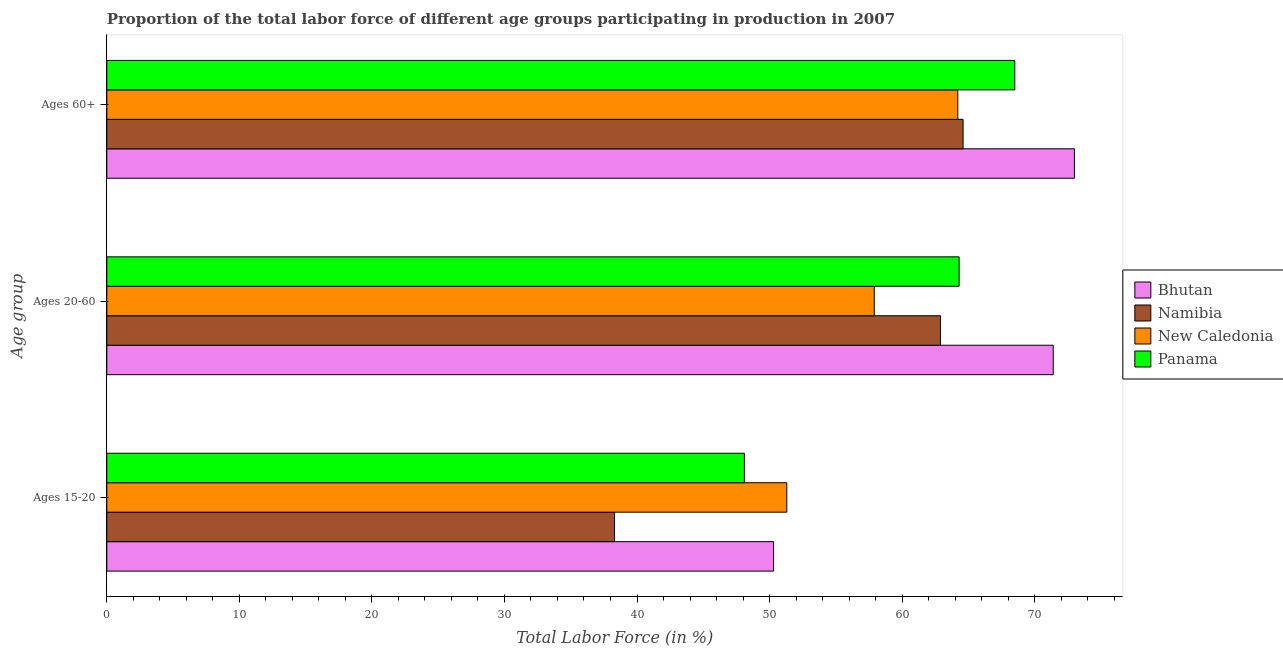Are the number of bars per tick equal to the number of legend labels?
Give a very brief answer. Yes. Are the number of bars on each tick of the Y-axis equal?
Ensure brevity in your answer.  Yes. How many bars are there on the 2nd tick from the top?
Offer a terse response. 4. What is the label of the 1st group of bars from the top?
Offer a terse response. Ages 60+. What is the percentage of labor force within the age group 20-60 in Bhutan?
Your answer should be compact. 71.4. Across all countries, what is the maximum percentage of labor force above age 60?
Provide a short and direct response. 73. Across all countries, what is the minimum percentage of labor force above age 60?
Provide a short and direct response. 64.2. In which country was the percentage of labor force above age 60 maximum?
Make the answer very short. Bhutan. In which country was the percentage of labor force above age 60 minimum?
Provide a succinct answer. New Caledonia. What is the total percentage of labor force above age 60 in the graph?
Ensure brevity in your answer.  270.3. What is the difference between the percentage of labor force within the age group 15-20 in New Caledonia and that in Namibia?
Ensure brevity in your answer.  13. What is the difference between the percentage of labor force within the age group 15-20 in Bhutan and the percentage of labor force above age 60 in New Caledonia?
Ensure brevity in your answer.  -13.9. What is the average percentage of labor force above age 60 per country?
Your response must be concise. 67.57. What is the difference between the percentage of labor force within the age group 20-60 and percentage of labor force within the age group 15-20 in Bhutan?
Provide a short and direct response. 21.1. In how many countries, is the percentage of labor force above age 60 greater than 24 %?
Your answer should be very brief. 4. What is the ratio of the percentage of labor force above age 60 in New Caledonia to that in Namibia?
Keep it short and to the point. 0.99. Is the percentage of labor force within the age group 20-60 in New Caledonia less than that in Bhutan?
Your response must be concise. Yes. Is the difference between the percentage of labor force above age 60 in Panama and New Caledonia greater than the difference between the percentage of labor force within the age group 20-60 in Panama and New Caledonia?
Your answer should be compact. No. What is the difference between the highest and the lowest percentage of labor force above age 60?
Your response must be concise. 8.8. Is the sum of the percentage of labor force within the age group 15-20 in Panama and Bhutan greater than the maximum percentage of labor force above age 60 across all countries?
Make the answer very short. Yes. What does the 4th bar from the top in Ages 60+ represents?
Your answer should be very brief. Bhutan. What does the 4th bar from the bottom in Ages 20-60 represents?
Your response must be concise. Panama. How many bars are there?
Offer a terse response. 12. Are all the bars in the graph horizontal?
Your answer should be very brief. Yes. How many countries are there in the graph?
Offer a very short reply. 4. What is the difference between two consecutive major ticks on the X-axis?
Your answer should be compact. 10. Does the graph contain grids?
Your response must be concise. No. Where does the legend appear in the graph?
Offer a terse response. Center right. How many legend labels are there?
Your answer should be very brief. 4. How are the legend labels stacked?
Your response must be concise. Vertical. What is the title of the graph?
Offer a very short reply. Proportion of the total labor force of different age groups participating in production in 2007. What is the label or title of the X-axis?
Provide a short and direct response. Total Labor Force (in %). What is the label or title of the Y-axis?
Your answer should be compact. Age group. What is the Total Labor Force (in %) in Bhutan in Ages 15-20?
Provide a short and direct response. 50.3. What is the Total Labor Force (in %) of Namibia in Ages 15-20?
Give a very brief answer. 38.3. What is the Total Labor Force (in %) of New Caledonia in Ages 15-20?
Your answer should be compact. 51.3. What is the Total Labor Force (in %) of Panama in Ages 15-20?
Give a very brief answer. 48.1. What is the Total Labor Force (in %) in Bhutan in Ages 20-60?
Keep it short and to the point. 71.4. What is the Total Labor Force (in %) in Namibia in Ages 20-60?
Your response must be concise. 62.9. What is the Total Labor Force (in %) in New Caledonia in Ages 20-60?
Your answer should be very brief. 57.9. What is the Total Labor Force (in %) of Panama in Ages 20-60?
Make the answer very short. 64.3. What is the Total Labor Force (in %) of Namibia in Ages 60+?
Provide a succinct answer. 64.6. What is the Total Labor Force (in %) of New Caledonia in Ages 60+?
Make the answer very short. 64.2. What is the Total Labor Force (in %) of Panama in Ages 60+?
Keep it short and to the point. 68.5. Across all Age group, what is the maximum Total Labor Force (in %) in Bhutan?
Your answer should be very brief. 73. Across all Age group, what is the maximum Total Labor Force (in %) of Namibia?
Give a very brief answer. 64.6. Across all Age group, what is the maximum Total Labor Force (in %) in New Caledonia?
Offer a terse response. 64.2. Across all Age group, what is the maximum Total Labor Force (in %) in Panama?
Your answer should be very brief. 68.5. Across all Age group, what is the minimum Total Labor Force (in %) in Bhutan?
Your answer should be compact. 50.3. Across all Age group, what is the minimum Total Labor Force (in %) of Namibia?
Provide a succinct answer. 38.3. Across all Age group, what is the minimum Total Labor Force (in %) in New Caledonia?
Ensure brevity in your answer.  51.3. Across all Age group, what is the minimum Total Labor Force (in %) in Panama?
Offer a very short reply. 48.1. What is the total Total Labor Force (in %) of Bhutan in the graph?
Keep it short and to the point. 194.7. What is the total Total Labor Force (in %) in Namibia in the graph?
Provide a short and direct response. 165.8. What is the total Total Labor Force (in %) of New Caledonia in the graph?
Your answer should be compact. 173.4. What is the total Total Labor Force (in %) in Panama in the graph?
Offer a terse response. 180.9. What is the difference between the Total Labor Force (in %) of Bhutan in Ages 15-20 and that in Ages 20-60?
Your answer should be very brief. -21.1. What is the difference between the Total Labor Force (in %) of Namibia in Ages 15-20 and that in Ages 20-60?
Give a very brief answer. -24.6. What is the difference between the Total Labor Force (in %) of Panama in Ages 15-20 and that in Ages 20-60?
Ensure brevity in your answer.  -16.2. What is the difference between the Total Labor Force (in %) of Bhutan in Ages 15-20 and that in Ages 60+?
Your answer should be compact. -22.7. What is the difference between the Total Labor Force (in %) of Namibia in Ages 15-20 and that in Ages 60+?
Give a very brief answer. -26.3. What is the difference between the Total Labor Force (in %) of New Caledonia in Ages 15-20 and that in Ages 60+?
Your answer should be very brief. -12.9. What is the difference between the Total Labor Force (in %) of Panama in Ages 15-20 and that in Ages 60+?
Your answer should be compact. -20.4. What is the difference between the Total Labor Force (in %) of Bhutan in Ages 20-60 and that in Ages 60+?
Your answer should be compact. -1.6. What is the difference between the Total Labor Force (in %) in New Caledonia in Ages 20-60 and that in Ages 60+?
Your answer should be compact. -6.3. What is the difference between the Total Labor Force (in %) of Namibia in Ages 15-20 and the Total Labor Force (in %) of New Caledonia in Ages 20-60?
Ensure brevity in your answer.  -19.6. What is the difference between the Total Labor Force (in %) of Namibia in Ages 15-20 and the Total Labor Force (in %) of Panama in Ages 20-60?
Your response must be concise. -26. What is the difference between the Total Labor Force (in %) in New Caledonia in Ages 15-20 and the Total Labor Force (in %) in Panama in Ages 20-60?
Offer a very short reply. -13. What is the difference between the Total Labor Force (in %) of Bhutan in Ages 15-20 and the Total Labor Force (in %) of Namibia in Ages 60+?
Your response must be concise. -14.3. What is the difference between the Total Labor Force (in %) in Bhutan in Ages 15-20 and the Total Labor Force (in %) in Panama in Ages 60+?
Provide a short and direct response. -18.2. What is the difference between the Total Labor Force (in %) in Namibia in Ages 15-20 and the Total Labor Force (in %) in New Caledonia in Ages 60+?
Ensure brevity in your answer.  -25.9. What is the difference between the Total Labor Force (in %) of Namibia in Ages 15-20 and the Total Labor Force (in %) of Panama in Ages 60+?
Your response must be concise. -30.2. What is the difference between the Total Labor Force (in %) in New Caledonia in Ages 15-20 and the Total Labor Force (in %) in Panama in Ages 60+?
Keep it short and to the point. -17.2. What is the difference between the Total Labor Force (in %) in Namibia in Ages 20-60 and the Total Labor Force (in %) in New Caledonia in Ages 60+?
Provide a succinct answer. -1.3. What is the difference between the Total Labor Force (in %) of Namibia in Ages 20-60 and the Total Labor Force (in %) of Panama in Ages 60+?
Provide a succinct answer. -5.6. What is the difference between the Total Labor Force (in %) of New Caledonia in Ages 20-60 and the Total Labor Force (in %) of Panama in Ages 60+?
Your answer should be very brief. -10.6. What is the average Total Labor Force (in %) of Bhutan per Age group?
Your response must be concise. 64.9. What is the average Total Labor Force (in %) of Namibia per Age group?
Offer a very short reply. 55.27. What is the average Total Labor Force (in %) in New Caledonia per Age group?
Make the answer very short. 57.8. What is the average Total Labor Force (in %) of Panama per Age group?
Ensure brevity in your answer.  60.3. What is the difference between the Total Labor Force (in %) in Bhutan and Total Labor Force (in %) in New Caledonia in Ages 15-20?
Your answer should be very brief. -1. What is the difference between the Total Labor Force (in %) in Bhutan and Total Labor Force (in %) in Panama in Ages 15-20?
Give a very brief answer. 2.2. What is the difference between the Total Labor Force (in %) of Namibia and Total Labor Force (in %) of New Caledonia in Ages 15-20?
Make the answer very short. -13. What is the difference between the Total Labor Force (in %) in New Caledonia and Total Labor Force (in %) in Panama in Ages 15-20?
Keep it short and to the point. 3.2. What is the difference between the Total Labor Force (in %) in Namibia and Total Labor Force (in %) in New Caledonia in Ages 20-60?
Provide a short and direct response. 5. What is the difference between the Total Labor Force (in %) of New Caledonia and Total Labor Force (in %) of Panama in Ages 20-60?
Provide a short and direct response. -6.4. What is the difference between the Total Labor Force (in %) of Bhutan and Total Labor Force (in %) of Panama in Ages 60+?
Give a very brief answer. 4.5. What is the difference between the Total Labor Force (in %) in Namibia and Total Labor Force (in %) in New Caledonia in Ages 60+?
Make the answer very short. 0.4. What is the difference between the Total Labor Force (in %) of Namibia and Total Labor Force (in %) of Panama in Ages 60+?
Give a very brief answer. -3.9. What is the difference between the Total Labor Force (in %) of New Caledonia and Total Labor Force (in %) of Panama in Ages 60+?
Offer a very short reply. -4.3. What is the ratio of the Total Labor Force (in %) of Bhutan in Ages 15-20 to that in Ages 20-60?
Offer a terse response. 0.7. What is the ratio of the Total Labor Force (in %) of Namibia in Ages 15-20 to that in Ages 20-60?
Provide a short and direct response. 0.61. What is the ratio of the Total Labor Force (in %) of New Caledonia in Ages 15-20 to that in Ages 20-60?
Make the answer very short. 0.89. What is the ratio of the Total Labor Force (in %) in Panama in Ages 15-20 to that in Ages 20-60?
Ensure brevity in your answer.  0.75. What is the ratio of the Total Labor Force (in %) of Bhutan in Ages 15-20 to that in Ages 60+?
Your response must be concise. 0.69. What is the ratio of the Total Labor Force (in %) of Namibia in Ages 15-20 to that in Ages 60+?
Offer a terse response. 0.59. What is the ratio of the Total Labor Force (in %) of New Caledonia in Ages 15-20 to that in Ages 60+?
Keep it short and to the point. 0.8. What is the ratio of the Total Labor Force (in %) of Panama in Ages 15-20 to that in Ages 60+?
Provide a short and direct response. 0.7. What is the ratio of the Total Labor Force (in %) in Bhutan in Ages 20-60 to that in Ages 60+?
Ensure brevity in your answer.  0.98. What is the ratio of the Total Labor Force (in %) of Namibia in Ages 20-60 to that in Ages 60+?
Keep it short and to the point. 0.97. What is the ratio of the Total Labor Force (in %) of New Caledonia in Ages 20-60 to that in Ages 60+?
Provide a succinct answer. 0.9. What is the ratio of the Total Labor Force (in %) of Panama in Ages 20-60 to that in Ages 60+?
Make the answer very short. 0.94. What is the difference between the highest and the second highest Total Labor Force (in %) in Namibia?
Provide a short and direct response. 1.7. What is the difference between the highest and the lowest Total Labor Force (in %) of Bhutan?
Your response must be concise. 22.7. What is the difference between the highest and the lowest Total Labor Force (in %) of Namibia?
Provide a short and direct response. 26.3. What is the difference between the highest and the lowest Total Labor Force (in %) of New Caledonia?
Your answer should be compact. 12.9. What is the difference between the highest and the lowest Total Labor Force (in %) in Panama?
Make the answer very short. 20.4. 